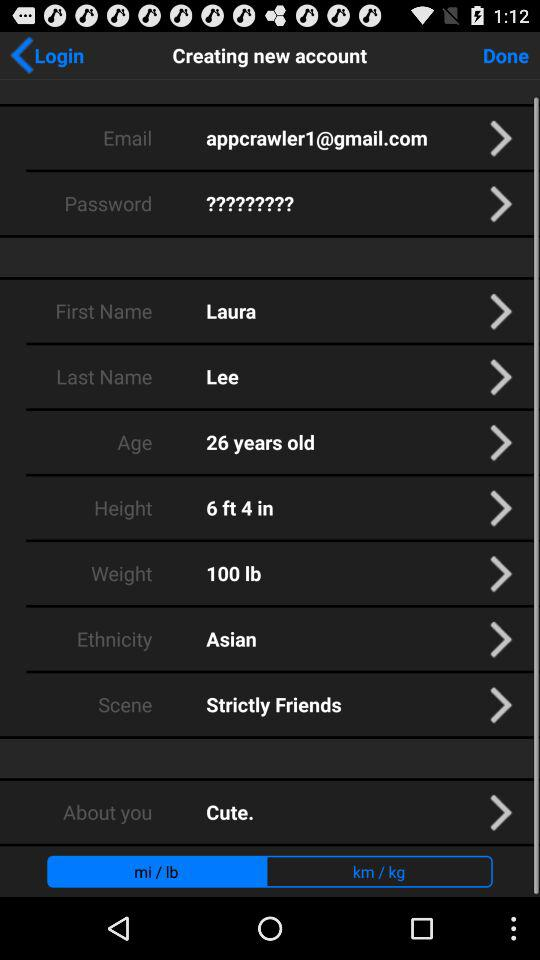What is the height? The height is 6 feet 4 inches. 